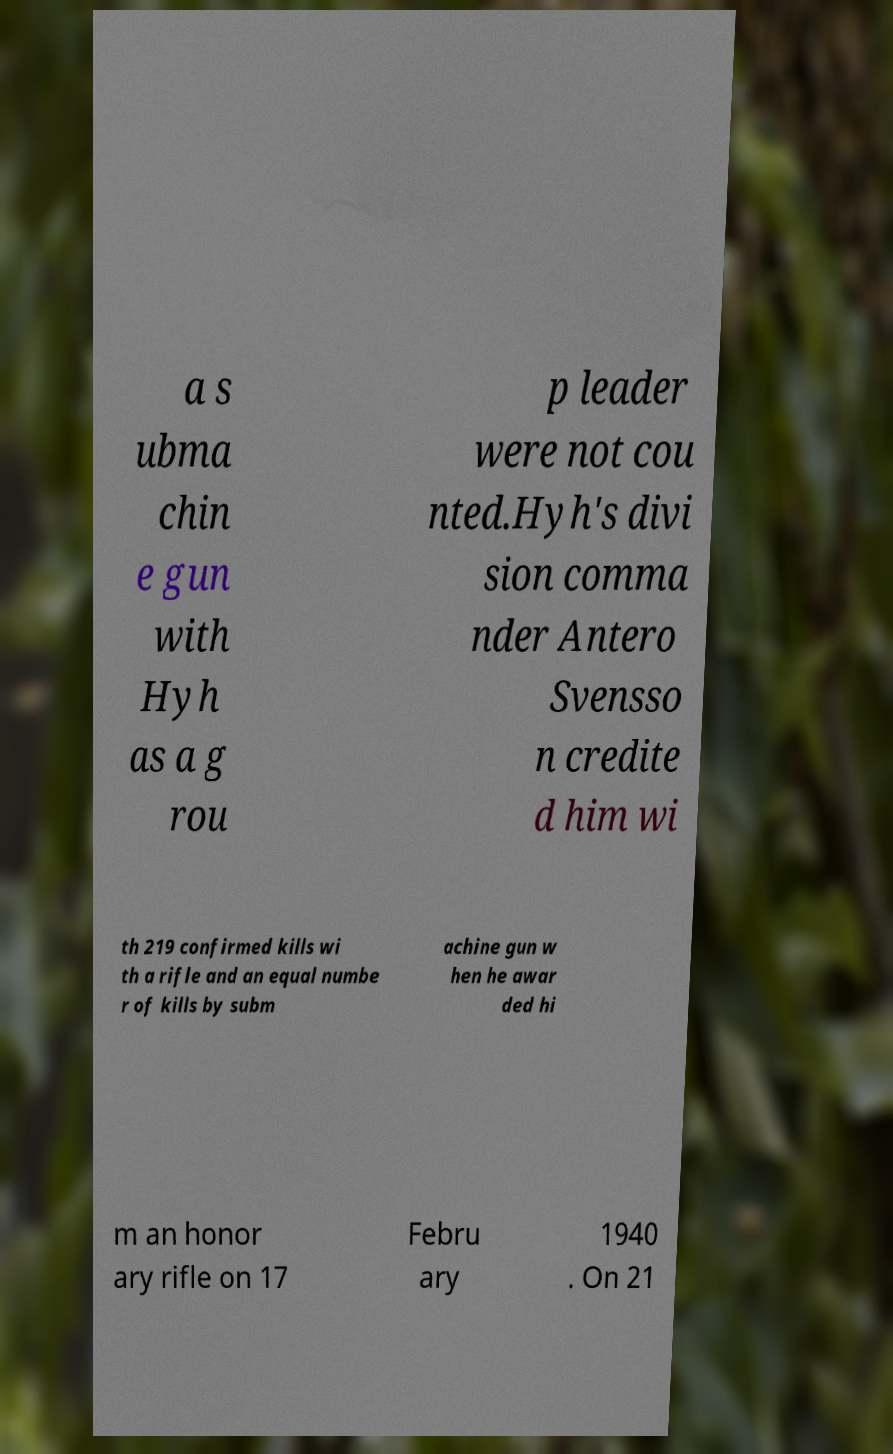Could you assist in decoding the text presented in this image and type it out clearly? a s ubma chin e gun with Hyh as a g rou p leader were not cou nted.Hyh's divi sion comma nder Antero Svensso n credite d him wi th 219 confirmed kills wi th a rifle and an equal numbe r of kills by subm achine gun w hen he awar ded hi m an honor ary rifle on 17 Febru ary 1940 . On 21 